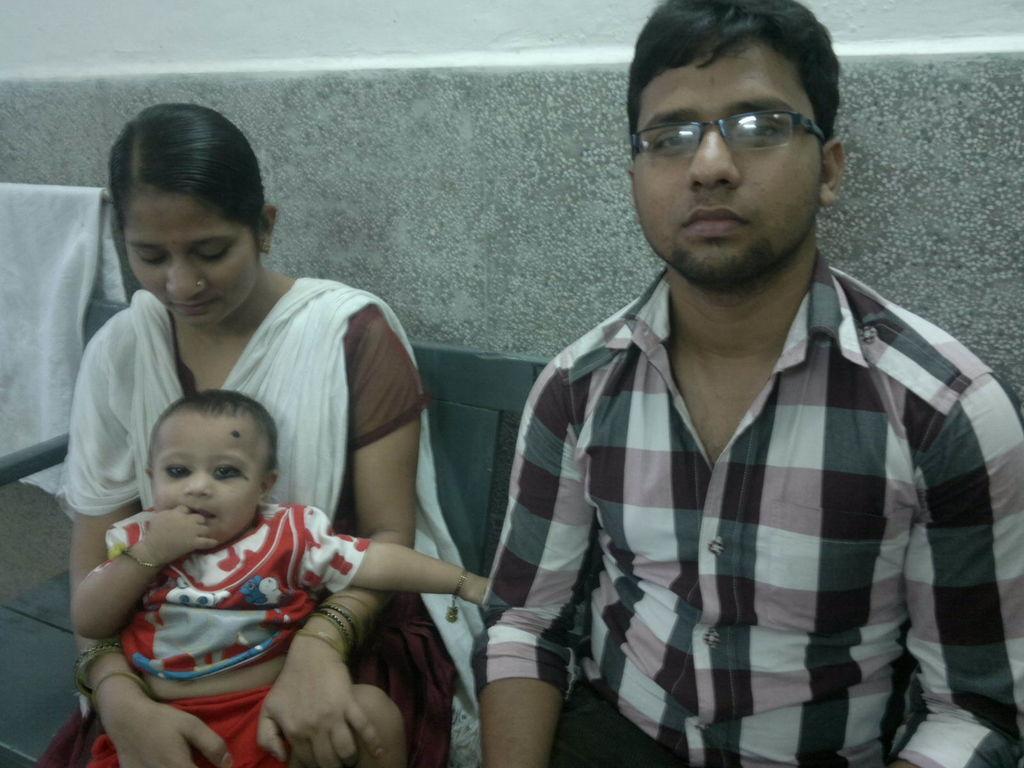How would you summarize this image in a sentence or two? There is one man and woman is sitting on a table as we can see in the middle of this image. The woman is holding a baby, and there is a wall in the background. There is one white color towel on the left side of this image. 